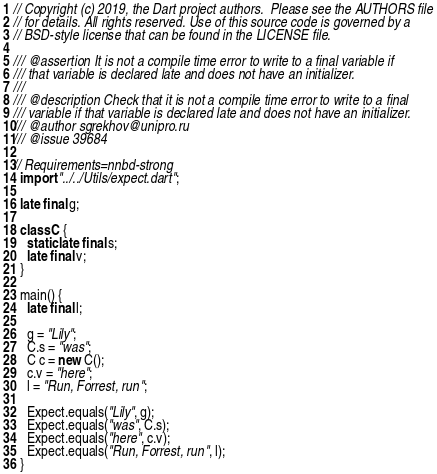<code> <loc_0><loc_0><loc_500><loc_500><_Dart_>// Copyright (c) 2019, the Dart project authors.  Please see the AUTHORS file
// for details. All rights reserved. Use of this source code is governed by a
// BSD-style license that can be found in the LICENSE file.

/// @assertion It is not a compile time error to write to a final variable if
/// that variable is declared late and does not have an initializer.
///
/// @description Check that it is not a compile time error to write to a final
/// variable if that variable is declared late and does not have an initializer.
/// @author sgrekhov@unipro.ru
/// @issue 39684

// Requirements=nnbd-strong
  import "../../Utils/expect.dart";

  late final g;

  class C {
    static late final s;
    late final v;
  }

  main() {
    late final l;

    g = "Lily";
    C.s = "was";
    C c = new C();
    c.v = "here";
    l = "Run, Forrest, run";

    Expect.equals("Lily", g);
    Expect.equals("was", C.s);
    Expect.equals("here", c.v);
    Expect.equals("Run, Forrest, run", l);
  }
</code> 